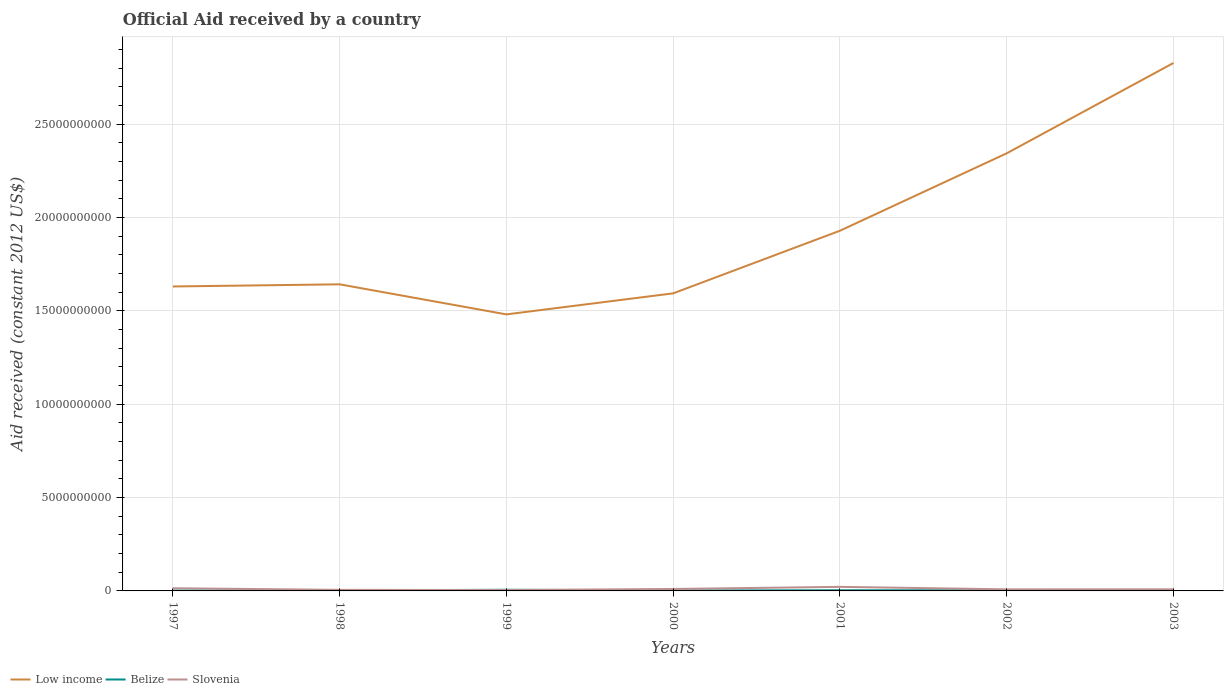Does the line corresponding to Slovenia intersect with the line corresponding to Low income?
Your answer should be very brief. No. Across all years, what is the maximum net official aid received in Slovenia?
Your answer should be very brief. 4.79e+07. In which year was the net official aid received in Belize maximum?
Ensure brevity in your answer.  2003. What is the total net official aid received in Low income in the graph?
Your answer should be very brief. -4.84e+09. What is the difference between the highest and the second highest net official aid received in Belize?
Offer a very short reply. 4.68e+07. How many years are there in the graph?
Offer a very short reply. 7. What is the difference between two consecutive major ticks on the Y-axis?
Provide a short and direct response. 5.00e+09. Are the values on the major ticks of Y-axis written in scientific E-notation?
Make the answer very short. No. Does the graph contain any zero values?
Offer a terse response. No. Where does the legend appear in the graph?
Give a very brief answer. Bottom left. How are the legend labels stacked?
Give a very brief answer. Horizontal. What is the title of the graph?
Offer a terse response. Official Aid received by a country. What is the label or title of the Y-axis?
Your answer should be compact. Aid received (constant 2012 US$). What is the Aid received (constant 2012 US$) of Low income in 1997?
Provide a short and direct response. 1.63e+1. What is the Aid received (constant 2012 US$) in Belize in 1997?
Make the answer very short. 2.03e+07. What is the Aid received (constant 2012 US$) of Slovenia in 1997?
Offer a very short reply. 1.43e+08. What is the Aid received (constant 2012 US$) in Low income in 1998?
Offer a very short reply. 1.64e+1. What is the Aid received (constant 2012 US$) in Belize in 1998?
Give a very brief answer. 2.22e+07. What is the Aid received (constant 2012 US$) of Slovenia in 1998?
Provide a succinct answer. 5.76e+07. What is the Aid received (constant 2012 US$) of Low income in 1999?
Ensure brevity in your answer.  1.48e+1. What is the Aid received (constant 2012 US$) in Belize in 1999?
Your answer should be very brief. 6.24e+07. What is the Aid received (constant 2012 US$) in Slovenia in 1999?
Provide a succinct answer. 4.79e+07. What is the Aid received (constant 2012 US$) of Low income in 2000?
Your answer should be very brief. 1.59e+1. What is the Aid received (constant 2012 US$) of Belize in 2000?
Make the answer very short. 2.36e+07. What is the Aid received (constant 2012 US$) in Slovenia in 2000?
Give a very brief answer. 1.04e+08. What is the Aid received (constant 2012 US$) in Low income in 2001?
Your answer should be very brief. 1.93e+1. What is the Aid received (constant 2012 US$) of Belize in 2001?
Provide a short and direct response. 3.48e+07. What is the Aid received (constant 2012 US$) in Slovenia in 2001?
Keep it short and to the point. 2.18e+08. What is the Aid received (constant 2012 US$) of Low income in 2002?
Ensure brevity in your answer.  2.34e+1. What is the Aid received (constant 2012 US$) of Belize in 2002?
Make the answer very short. 3.36e+07. What is the Aid received (constant 2012 US$) of Slovenia in 2002?
Keep it short and to the point. 8.46e+07. What is the Aid received (constant 2012 US$) of Low income in 2003?
Give a very brief answer. 2.83e+1. What is the Aid received (constant 2012 US$) in Belize in 2003?
Offer a very short reply. 1.56e+07. What is the Aid received (constant 2012 US$) in Slovenia in 2003?
Offer a terse response. 8.71e+07. Across all years, what is the maximum Aid received (constant 2012 US$) in Low income?
Your answer should be very brief. 2.83e+1. Across all years, what is the maximum Aid received (constant 2012 US$) in Belize?
Keep it short and to the point. 6.24e+07. Across all years, what is the maximum Aid received (constant 2012 US$) in Slovenia?
Offer a terse response. 2.18e+08. Across all years, what is the minimum Aid received (constant 2012 US$) in Low income?
Ensure brevity in your answer.  1.48e+1. Across all years, what is the minimum Aid received (constant 2012 US$) in Belize?
Provide a succinct answer. 1.56e+07. Across all years, what is the minimum Aid received (constant 2012 US$) of Slovenia?
Give a very brief answer. 4.79e+07. What is the total Aid received (constant 2012 US$) of Low income in the graph?
Provide a succinct answer. 1.35e+11. What is the total Aid received (constant 2012 US$) in Belize in the graph?
Give a very brief answer. 2.13e+08. What is the total Aid received (constant 2012 US$) in Slovenia in the graph?
Offer a terse response. 7.42e+08. What is the difference between the Aid received (constant 2012 US$) in Low income in 1997 and that in 1998?
Ensure brevity in your answer.  -1.15e+08. What is the difference between the Aid received (constant 2012 US$) in Belize in 1997 and that in 1998?
Give a very brief answer. -1.86e+06. What is the difference between the Aid received (constant 2012 US$) of Slovenia in 1997 and that in 1998?
Provide a succinct answer. 8.52e+07. What is the difference between the Aid received (constant 2012 US$) in Low income in 1997 and that in 1999?
Make the answer very short. 1.50e+09. What is the difference between the Aid received (constant 2012 US$) in Belize in 1997 and that in 1999?
Make the answer very short. -4.21e+07. What is the difference between the Aid received (constant 2012 US$) in Slovenia in 1997 and that in 1999?
Make the answer very short. 9.50e+07. What is the difference between the Aid received (constant 2012 US$) in Low income in 1997 and that in 2000?
Provide a short and direct response. 3.69e+08. What is the difference between the Aid received (constant 2012 US$) in Belize in 1997 and that in 2000?
Provide a succinct answer. -3.32e+06. What is the difference between the Aid received (constant 2012 US$) in Slovenia in 1997 and that in 2000?
Offer a terse response. 3.85e+07. What is the difference between the Aid received (constant 2012 US$) of Low income in 1997 and that in 2001?
Your answer should be very brief. -2.98e+09. What is the difference between the Aid received (constant 2012 US$) of Belize in 1997 and that in 2001?
Make the answer very short. -1.45e+07. What is the difference between the Aid received (constant 2012 US$) of Slovenia in 1997 and that in 2001?
Offer a terse response. -7.48e+07. What is the difference between the Aid received (constant 2012 US$) of Low income in 1997 and that in 2002?
Provide a short and direct response. -7.13e+09. What is the difference between the Aid received (constant 2012 US$) of Belize in 1997 and that in 2002?
Ensure brevity in your answer.  -1.32e+07. What is the difference between the Aid received (constant 2012 US$) of Slovenia in 1997 and that in 2002?
Give a very brief answer. 5.83e+07. What is the difference between the Aid received (constant 2012 US$) in Low income in 1997 and that in 2003?
Provide a succinct answer. -1.20e+1. What is the difference between the Aid received (constant 2012 US$) of Belize in 1997 and that in 2003?
Offer a terse response. 4.70e+06. What is the difference between the Aid received (constant 2012 US$) in Slovenia in 1997 and that in 2003?
Your response must be concise. 5.58e+07. What is the difference between the Aid received (constant 2012 US$) in Low income in 1998 and that in 1999?
Your answer should be compact. 1.61e+09. What is the difference between the Aid received (constant 2012 US$) in Belize in 1998 and that in 1999?
Your answer should be very brief. -4.02e+07. What is the difference between the Aid received (constant 2012 US$) in Slovenia in 1998 and that in 1999?
Your answer should be compact. 9.79e+06. What is the difference between the Aid received (constant 2012 US$) in Low income in 1998 and that in 2000?
Provide a succinct answer. 4.84e+08. What is the difference between the Aid received (constant 2012 US$) in Belize in 1998 and that in 2000?
Give a very brief answer. -1.46e+06. What is the difference between the Aid received (constant 2012 US$) of Slovenia in 1998 and that in 2000?
Provide a succinct answer. -4.67e+07. What is the difference between the Aid received (constant 2012 US$) of Low income in 1998 and that in 2001?
Give a very brief answer. -2.87e+09. What is the difference between the Aid received (constant 2012 US$) in Belize in 1998 and that in 2001?
Make the answer very short. -1.26e+07. What is the difference between the Aid received (constant 2012 US$) in Slovenia in 1998 and that in 2001?
Offer a very short reply. -1.60e+08. What is the difference between the Aid received (constant 2012 US$) in Low income in 1998 and that in 2002?
Your answer should be very brief. -7.02e+09. What is the difference between the Aid received (constant 2012 US$) in Belize in 1998 and that in 2002?
Keep it short and to the point. -1.14e+07. What is the difference between the Aid received (constant 2012 US$) in Slovenia in 1998 and that in 2002?
Offer a very short reply. -2.69e+07. What is the difference between the Aid received (constant 2012 US$) in Low income in 1998 and that in 2003?
Offer a terse response. -1.19e+1. What is the difference between the Aid received (constant 2012 US$) in Belize in 1998 and that in 2003?
Provide a short and direct response. 6.56e+06. What is the difference between the Aid received (constant 2012 US$) in Slovenia in 1998 and that in 2003?
Ensure brevity in your answer.  -2.95e+07. What is the difference between the Aid received (constant 2012 US$) in Low income in 1999 and that in 2000?
Ensure brevity in your answer.  -1.13e+09. What is the difference between the Aid received (constant 2012 US$) in Belize in 1999 and that in 2000?
Keep it short and to the point. 3.87e+07. What is the difference between the Aid received (constant 2012 US$) of Slovenia in 1999 and that in 2000?
Provide a short and direct response. -5.65e+07. What is the difference between the Aid received (constant 2012 US$) of Low income in 1999 and that in 2001?
Offer a very short reply. -4.48e+09. What is the difference between the Aid received (constant 2012 US$) in Belize in 1999 and that in 2001?
Offer a terse response. 2.76e+07. What is the difference between the Aid received (constant 2012 US$) in Slovenia in 1999 and that in 2001?
Ensure brevity in your answer.  -1.70e+08. What is the difference between the Aid received (constant 2012 US$) in Low income in 1999 and that in 2002?
Provide a short and direct response. -8.63e+09. What is the difference between the Aid received (constant 2012 US$) in Belize in 1999 and that in 2002?
Make the answer very short. 2.88e+07. What is the difference between the Aid received (constant 2012 US$) of Slovenia in 1999 and that in 2002?
Ensure brevity in your answer.  -3.67e+07. What is the difference between the Aid received (constant 2012 US$) of Low income in 1999 and that in 2003?
Provide a succinct answer. -1.35e+1. What is the difference between the Aid received (constant 2012 US$) in Belize in 1999 and that in 2003?
Ensure brevity in your answer.  4.68e+07. What is the difference between the Aid received (constant 2012 US$) of Slovenia in 1999 and that in 2003?
Give a very brief answer. -3.93e+07. What is the difference between the Aid received (constant 2012 US$) of Low income in 2000 and that in 2001?
Keep it short and to the point. -3.35e+09. What is the difference between the Aid received (constant 2012 US$) of Belize in 2000 and that in 2001?
Your response must be concise. -1.12e+07. What is the difference between the Aid received (constant 2012 US$) of Slovenia in 2000 and that in 2001?
Offer a terse response. -1.13e+08. What is the difference between the Aid received (constant 2012 US$) in Low income in 2000 and that in 2002?
Make the answer very short. -7.50e+09. What is the difference between the Aid received (constant 2012 US$) in Belize in 2000 and that in 2002?
Provide a succinct answer. -9.92e+06. What is the difference between the Aid received (constant 2012 US$) of Slovenia in 2000 and that in 2002?
Make the answer very short. 1.98e+07. What is the difference between the Aid received (constant 2012 US$) in Low income in 2000 and that in 2003?
Provide a short and direct response. -1.23e+1. What is the difference between the Aid received (constant 2012 US$) of Belize in 2000 and that in 2003?
Your answer should be compact. 8.02e+06. What is the difference between the Aid received (constant 2012 US$) of Slovenia in 2000 and that in 2003?
Your response must be concise. 1.72e+07. What is the difference between the Aid received (constant 2012 US$) in Low income in 2001 and that in 2002?
Give a very brief answer. -4.15e+09. What is the difference between the Aid received (constant 2012 US$) of Belize in 2001 and that in 2002?
Your answer should be compact. 1.25e+06. What is the difference between the Aid received (constant 2012 US$) of Slovenia in 2001 and that in 2002?
Provide a succinct answer. 1.33e+08. What is the difference between the Aid received (constant 2012 US$) in Low income in 2001 and that in 2003?
Provide a short and direct response. -8.99e+09. What is the difference between the Aid received (constant 2012 US$) in Belize in 2001 and that in 2003?
Your answer should be compact. 1.92e+07. What is the difference between the Aid received (constant 2012 US$) of Slovenia in 2001 and that in 2003?
Give a very brief answer. 1.30e+08. What is the difference between the Aid received (constant 2012 US$) in Low income in 2002 and that in 2003?
Offer a terse response. -4.84e+09. What is the difference between the Aid received (constant 2012 US$) in Belize in 2002 and that in 2003?
Ensure brevity in your answer.  1.79e+07. What is the difference between the Aid received (constant 2012 US$) of Slovenia in 2002 and that in 2003?
Offer a terse response. -2.54e+06. What is the difference between the Aid received (constant 2012 US$) in Low income in 1997 and the Aid received (constant 2012 US$) in Belize in 1998?
Give a very brief answer. 1.63e+1. What is the difference between the Aid received (constant 2012 US$) in Low income in 1997 and the Aid received (constant 2012 US$) in Slovenia in 1998?
Give a very brief answer. 1.63e+1. What is the difference between the Aid received (constant 2012 US$) in Belize in 1997 and the Aid received (constant 2012 US$) in Slovenia in 1998?
Your answer should be compact. -3.73e+07. What is the difference between the Aid received (constant 2012 US$) in Low income in 1997 and the Aid received (constant 2012 US$) in Belize in 1999?
Keep it short and to the point. 1.62e+1. What is the difference between the Aid received (constant 2012 US$) of Low income in 1997 and the Aid received (constant 2012 US$) of Slovenia in 1999?
Ensure brevity in your answer.  1.63e+1. What is the difference between the Aid received (constant 2012 US$) in Belize in 1997 and the Aid received (constant 2012 US$) in Slovenia in 1999?
Provide a short and direct response. -2.75e+07. What is the difference between the Aid received (constant 2012 US$) of Low income in 1997 and the Aid received (constant 2012 US$) of Belize in 2000?
Ensure brevity in your answer.  1.63e+1. What is the difference between the Aid received (constant 2012 US$) of Low income in 1997 and the Aid received (constant 2012 US$) of Slovenia in 2000?
Ensure brevity in your answer.  1.62e+1. What is the difference between the Aid received (constant 2012 US$) of Belize in 1997 and the Aid received (constant 2012 US$) of Slovenia in 2000?
Provide a short and direct response. -8.40e+07. What is the difference between the Aid received (constant 2012 US$) of Low income in 1997 and the Aid received (constant 2012 US$) of Belize in 2001?
Ensure brevity in your answer.  1.63e+1. What is the difference between the Aid received (constant 2012 US$) in Low income in 1997 and the Aid received (constant 2012 US$) in Slovenia in 2001?
Your response must be concise. 1.61e+1. What is the difference between the Aid received (constant 2012 US$) of Belize in 1997 and the Aid received (constant 2012 US$) of Slovenia in 2001?
Keep it short and to the point. -1.97e+08. What is the difference between the Aid received (constant 2012 US$) in Low income in 1997 and the Aid received (constant 2012 US$) in Belize in 2002?
Ensure brevity in your answer.  1.63e+1. What is the difference between the Aid received (constant 2012 US$) in Low income in 1997 and the Aid received (constant 2012 US$) in Slovenia in 2002?
Ensure brevity in your answer.  1.62e+1. What is the difference between the Aid received (constant 2012 US$) in Belize in 1997 and the Aid received (constant 2012 US$) in Slovenia in 2002?
Offer a terse response. -6.42e+07. What is the difference between the Aid received (constant 2012 US$) in Low income in 1997 and the Aid received (constant 2012 US$) in Belize in 2003?
Provide a succinct answer. 1.63e+1. What is the difference between the Aid received (constant 2012 US$) of Low income in 1997 and the Aid received (constant 2012 US$) of Slovenia in 2003?
Provide a short and direct response. 1.62e+1. What is the difference between the Aid received (constant 2012 US$) in Belize in 1997 and the Aid received (constant 2012 US$) in Slovenia in 2003?
Provide a succinct answer. -6.68e+07. What is the difference between the Aid received (constant 2012 US$) in Low income in 1998 and the Aid received (constant 2012 US$) in Belize in 1999?
Your response must be concise. 1.64e+1. What is the difference between the Aid received (constant 2012 US$) in Low income in 1998 and the Aid received (constant 2012 US$) in Slovenia in 1999?
Give a very brief answer. 1.64e+1. What is the difference between the Aid received (constant 2012 US$) in Belize in 1998 and the Aid received (constant 2012 US$) in Slovenia in 1999?
Give a very brief answer. -2.57e+07. What is the difference between the Aid received (constant 2012 US$) in Low income in 1998 and the Aid received (constant 2012 US$) in Belize in 2000?
Your answer should be compact. 1.64e+1. What is the difference between the Aid received (constant 2012 US$) in Low income in 1998 and the Aid received (constant 2012 US$) in Slovenia in 2000?
Offer a terse response. 1.63e+1. What is the difference between the Aid received (constant 2012 US$) of Belize in 1998 and the Aid received (constant 2012 US$) of Slovenia in 2000?
Keep it short and to the point. -8.22e+07. What is the difference between the Aid received (constant 2012 US$) of Low income in 1998 and the Aid received (constant 2012 US$) of Belize in 2001?
Make the answer very short. 1.64e+1. What is the difference between the Aid received (constant 2012 US$) of Low income in 1998 and the Aid received (constant 2012 US$) of Slovenia in 2001?
Keep it short and to the point. 1.62e+1. What is the difference between the Aid received (constant 2012 US$) of Belize in 1998 and the Aid received (constant 2012 US$) of Slovenia in 2001?
Offer a very short reply. -1.95e+08. What is the difference between the Aid received (constant 2012 US$) in Low income in 1998 and the Aid received (constant 2012 US$) in Belize in 2002?
Offer a terse response. 1.64e+1. What is the difference between the Aid received (constant 2012 US$) of Low income in 1998 and the Aid received (constant 2012 US$) of Slovenia in 2002?
Your answer should be compact. 1.63e+1. What is the difference between the Aid received (constant 2012 US$) of Belize in 1998 and the Aid received (constant 2012 US$) of Slovenia in 2002?
Provide a succinct answer. -6.24e+07. What is the difference between the Aid received (constant 2012 US$) in Low income in 1998 and the Aid received (constant 2012 US$) in Belize in 2003?
Your answer should be very brief. 1.64e+1. What is the difference between the Aid received (constant 2012 US$) of Low income in 1998 and the Aid received (constant 2012 US$) of Slovenia in 2003?
Your answer should be very brief. 1.63e+1. What is the difference between the Aid received (constant 2012 US$) of Belize in 1998 and the Aid received (constant 2012 US$) of Slovenia in 2003?
Your answer should be very brief. -6.49e+07. What is the difference between the Aid received (constant 2012 US$) in Low income in 1999 and the Aid received (constant 2012 US$) in Belize in 2000?
Give a very brief answer. 1.48e+1. What is the difference between the Aid received (constant 2012 US$) of Low income in 1999 and the Aid received (constant 2012 US$) of Slovenia in 2000?
Your answer should be compact. 1.47e+1. What is the difference between the Aid received (constant 2012 US$) in Belize in 1999 and the Aid received (constant 2012 US$) in Slovenia in 2000?
Give a very brief answer. -4.20e+07. What is the difference between the Aid received (constant 2012 US$) in Low income in 1999 and the Aid received (constant 2012 US$) in Belize in 2001?
Keep it short and to the point. 1.48e+1. What is the difference between the Aid received (constant 2012 US$) of Low income in 1999 and the Aid received (constant 2012 US$) of Slovenia in 2001?
Make the answer very short. 1.46e+1. What is the difference between the Aid received (constant 2012 US$) in Belize in 1999 and the Aid received (constant 2012 US$) in Slovenia in 2001?
Provide a succinct answer. -1.55e+08. What is the difference between the Aid received (constant 2012 US$) in Low income in 1999 and the Aid received (constant 2012 US$) in Belize in 2002?
Give a very brief answer. 1.48e+1. What is the difference between the Aid received (constant 2012 US$) of Low income in 1999 and the Aid received (constant 2012 US$) of Slovenia in 2002?
Give a very brief answer. 1.47e+1. What is the difference between the Aid received (constant 2012 US$) of Belize in 1999 and the Aid received (constant 2012 US$) of Slovenia in 2002?
Keep it short and to the point. -2.22e+07. What is the difference between the Aid received (constant 2012 US$) in Low income in 1999 and the Aid received (constant 2012 US$) in Belize in 2003?
Provide a succinct answer. 1.48e+1. What is the difference between the Aid received (constant 2012 US$) in Low income in 1999 and the Aid received (constant 2012 US$) in Slovenia in 2003?
Provide a succinct answer. 1.47e+1. What is the difference between the Aid received (constant 2012 US$) of Belize in 1999 and the Aid received (constant 2012 US$) of Slovenia in 2003?
Ensure brevity in your answer.  -2.47e+07. What is the difference between the Aid received (constant 2012 US$) of Low income in 2000 and the Aid received (constant 2012 US$) of Belize in 2001?
Offer a terse response. 1.59e+1. What is the difference between the Aid received (constant 2012 US$) in Low income in 2000 and the Aid received (constant 2012 US$) in Slovenia in 2001?
Offer a very short reply. 1.57e+1. What is the difference between the Aid received (constant 2012 US$) of Belize in 2000 and the Aid received (constant 2012 US$) of Slovenia in 2001?
Offer a terse response. -1.94e+08. What is the difference between the Aid received (constant 2012 US$) of Low income in 2000 and the Aid received (constant 2012 US$) of Belize in 2002?
Offer a very short reply. 1.59e+1. What is the difference between the Aid received (constant 2012 US$) of Low income in 2000 and the Aid received (constant 2012 US$) of Slovenia in 2002?
Make the answer very short. 1.59e+1. What is the difference between the Aid received (constant 2012 US$) in Belize in 2000 and the Aid received (constant 2012 US$) in Slovenia in 2002?
Give a very brief answer. -6.09e+07. What is the difference between the Aid received (constant 2012 US$) of Low income in 2000 and the Aid received (constant 2012 US$) of Belize in 2003?
Your answer should be compact. 1.59e+1. What is the difference between the Aid received (constant 2012 US$) of Low income in 2000 and the Aid received (constant 2012 US$) of Slovenia in 2003?
Your answer should be very brief. 1.59e+1. What is the difference between the Aid received (constant 2012 US$) of Belize in 2000 and the Aid received (constant 2012 US$) of Slovenia in 2003?
Keep it short and to the point. -6.35e+07. What is the difference between the Aid received (constant 2012 US$) of Low income in 2001 and the Aid received (constant 2012 US$) of Belize in 2002?
Offer a terse response. 1.93e+1. What is the difference between the Aid received (constant 2012 US$) in Low income in 2001 and the Aid received (constant 2012 US$) in Slovenia in 2002?
Offer a terse response. 1.92e+1. What is the difference between the Aid received (constant 2012 US$) of Belize in 2001 and the Aid received (constant 2012 US$) of Slovenia in 2002?
Keep it short and to the point. -4.98e+07. What is the difference between the Aid received (constant 2012 US$) of Low income in 2001 and the Aid received (constant 2012 US$) of Belize in 2003?
Provide a short and direct response. 1.93e+1. What is the difference between the Aid received (constant 2012 US$) in Low income in 2001 and the Aid received (constant 2012 US$) in Slovenia in 2003?
Keep it short and to the point. 1.92e+1. What is the difference between the Aid received (constant 2012 US$) in Belize in 2001 and the Aid received (constant 2012 US$) in Slovenia in 2003?
Keep it short and to the point. -5.23e+07. What is the difference between the Aid received (constant 2012 US$) of Low income in 2002 and the Aid received (constant 2012 US$) of Belize in 2003?
Provide a short and direct response. 2.34e+1. What is the difference between the Aid received (constant 2012 US$) in Low income in 2002 and the Aid received (constant 2012 US$) in Slovenia in 2003?
Ensure brevity in your answer.  2.34e+1. What is the difference between the Aid received (constant 2012 US$) of Belize in 2002 and the Aid received (constant 2012 US$) of Slovenia in 2003?
Offer a terse response. -5.36e+07. What is the average Aid received (constant 2012 US$) in Low income per year?
Offer a very short reply. 1.92e+1. What is the average Aid received (constant 2012 US$) of Belize per year?
Keep it short and to the point. 3.04e+07. What is the average Aid received (constant 2012 US$) in Slovenia per year?
Provide a succinct answer. 1.06e+08. In the year 1997, what is the difference between the Aid received (constant 2012 US$) in Low income and Aid received (constant 2012 US$) in Belize?
Give a very brief answer. 1.63e+1. In the year 1997, what is the difference between the Aid received (constant 2012 US$) of Low income and Aid received (constant 2012 US$) of Slovenia?
Offer a terse response. 1.62e+1. In the year 1997, what is the difference between the Aid received (constant 2012 US$) in Belize and Aid received (constant 2012 US$) in Slovenia?
Your answer should be compact. -1.23e+08. In the year 1998, what is the difference between the Aid received (constant 2012 US$) in Low income and Aid received (constant 2012 US$) in Belize?
Keep it short and to the point. 1.64e+1. In the year 1998, what is the difference between the Aid received (constant 2012 US$) of Low income and Aid received (constant 2012 US$) of Slovenia?
Ensure brevity in your answer.  1.64e+1. In the year 1998, what is the difference between the Aid received (constant 2012 US$) of Belize and Aid received (constant 2012 US$) of Slovenia?
Your response must be concise. -3.55e+07. In the year 1999, what is the difference between the Aid received (constant 2012 US$) of Low income and Aid received (constant 2012 US$) of Belize?
Ensure brevity in your answer.  1.48e+1. In the year 1999, what is the difference between the Aid received (constant 2012 US$) of Low income and Aid received (constant 2012 US$) of Slovenia?
Offer a terse response. 1.48e+1. In the year 1999, what is the difference between the Aid received (constant 2012 US$) in Belize and Aid received (constant 2012 US$) in Slovenia?
Make the answer very short. 1.45e+07. In the year 2000, what is the difference between the Aid received (constant 2012 US$) in Low income and Aid received (constant 2012 US$) in Belize?
Your answer should be very brief. 1.59e+1. In the year 2000, what is the difference between the Aid received (constant 2012 US$) of Low income and Aid received (constant 2012 US$) of Slovenia?
Make the answer very short. 1.58e+1. In the year 2000, what is the difference between the Aid received (constant 2012 US$) in Belize and Aid received (constant 2012 US$) in Slovenia?
Your answer should be very brief. -8.07e+07. In the year 2001, what is the difference between the Aid received (constant 2012 US$) of Low income and Aid received (constant 2012 US$) of Belize?
Provide a short and direct response. 1.93e+1. In the year 2001, what is the difference between the Aid received (constant 2012 US$) in Low income and Aid received (constant 2012 US$) in Slovenia?
Provide a succinct answer. 1.91e+1. In the year 2001, what is the difference between the Aid received (constant 2012 US$) of Belize and Aid received (constant 2012 US$) of Slovenia?
Make the answer very short. -1.83e+08. In the year 2002, what is the difference between the Aid received (constant 2012 US$) of Low income and Aid received (constant 2012 US$) of Belize?
Give a very brief answer. 2.34e+1. In the year 2002, what is the difference between the Aid received (constant 2012 US$) of Low income and Aid received (constant 2012 US$) of Slovenia?
Offer a terse response. 2.34e+1. In the year 2002, what is the difference between the Aid received (constant 2012 US$) of Belize and Aid received (constant 2012 US$) of Slovenia?
Your answer should be very brief. -5.10e+07. In the year 2003, what is the difference between the Aid received (constant 2012 US$) in Low income and Aid received (constant 2012 US$) in Belize?
Your answer should be compact. 2.83e+1. In the year 2003, what is the difference between the Aid received (constant 2012 US$) of Low income and Aid received (constant 2012 US$) of Slovenia?
Provide a succinct answer. 2.82e+1. In the year 2003, what is the difference between the Aid received (constant 2012 US$) in Belize and Aid received (constant 2012 US$) in Slovenia?
Offer a very short reply. -7.15e+07. What is the ratio of the Aid received (constant 2012 US$) in Low income in 1997 to that in 1998?
Provide a succinct answer. 0.99. What is the ratio of the Aid received (constant 2012 US$) of Belize in 1997 to that in 1998?
Provide a short and direct response. 0.92. What is the ratio of the Aid received (constant 2012 US$) in Slovenia in 1997 to that in 1998?
Ensure brevity in your answer.  2.48. What is the ratio of the Aid received (constant 2012 US$) in Low income in 1997 to that in 1999?
Ensure brevity in your answer.  1.1. What is the ratio of the Aid received (constant 2012 US$) of Belize in 1997 to that in 1999?
Your response must be concise. 0.33. What is the ratio of the Aid received (constant 2012 US$) in Slovenia in 1997 to that in 1999?
Keep it short and to the point. 2.99. What is the ratio of the Aid received (constant 2012 US$) of Low income in 1997 to that in 2000?
Give a very brief answer. 1.02. What is the ratio of the Aid received (constant 2012 US$) of Belize in 1997 to that in 2000?
Your answer should be very brief. 0.86. What is the ratio of the Aid received (constant 2012 US$) in Slovenia in 1997 to that in 2000?
Your response must be concise. 1.37. What is the ratio of the Aid received (constant 2012 US$) of Low income in 1997 to that in 2001?
Make the answer very short. 0.85. What is the ratio of the Aid received (constant 2012 US$) of Belize in 1997 to that in 2001?
Your response must be concise. 0.58. What is the ratio of the Aid received (constant 2012 US$) in Slovenia in 1997 to that in 2001?
Your answer should be very brief. 0.66. What is the ratio of the Aid received (constant 2012 US$) in Low income in 1997 to that in 2002?
Ensure brevity in your answer.  0.7. What is the ratio of the Aid received (constant 2012 US$) of Belize in 1997 to that in 2002?
Make the answer very short. 0.61. What is the ratio of the Aid received (constant 2012 US$) of Slovenia in 1997 to that in 2002?
Your answer should be very brief. 1.69. What is the ratio of the Aid received (constant 2012 US$) of Low income in 1997 to that in 2003?
Offer a terse response. 0.58. What is the ratio of the Aid received (constant 2012 US$) in Belize in 1997 to that in 2003?
Your response must be concise. 1.3. What is the ratio of the Aid received (constant 2012 US$) of Slovenia in 1997 to that in 2003?
Offer a very short reply. 1.64. What is the ratio of the Aid received (constant 2012 US$) of Low income in 1998 to that in 1999?
Offer a terse response. 1.11. What is the ratio of the Aid received (constant 2012 US$) of Belize in 1998 to that in 1999?
Provide a short and direct response. 0.36. What is the ratio of the Aid received (constant 2012 US$) of Slovenia in 1998 to that in 1999?
Provide a short and direct response. 1.2. What is the ratio of the Aid received (constant 2012 US$) of Low income in 1998 to that in 2000?
Your response must be concise. 1.03. What is the ratio of the Aid received (constant 2012 US$) in Belize in 1998 to that in 2000?
Your response must be concise. 0.94. What is the ratio of the Aid received (constant 2012 US$) in Slovenia in 1998 to that in 2000?
Provide a short and direct response. 0.55. What is the ratio of the Aid received (constant 2012 US$) of Low income in 1998 to that in 2001?
Provide a succinct answer. 0.85. What is the ratio of the Aid received (constant 2012 US$) of Belize in 1998 to that in 2001?
Provide a short and direct response. 0.64. What is the ratio of the Aid received (constant 2012 US$) in Slovenia in 1998 to that in 2001?
Offer a very short reply. 0.26. What is the ratio of the Aid received (constant 2012 US$) of Low income in 1998 to that in 2002?
Your answer should be very brief. 0.7. What is the ratio of the Aid received (constant 2012 US$) in Belize in 1998 to that in 2002?
Provide a succinct answer. 0.66. What is the ratio of the Aid received (constant 2012 US$) in Slovenia in 1998 to that in 2002?
Your answer should be compact. 0.68. What is the ratio of the Aid received (constant 2012 US$) in Low income in 1998 to that in 2003?
Provide a short and direct response. 0.58. What is the ratio of the Aid received (constant 2012 US$) in Belize in 1998 to that in 2003?
Provide a short and direct response. 1.42. What is the ratio of the Aid received (constant 2012 US$) of Slovenia in 1998 to that in 2003?
Offer a very short reply. 0.66. What is the ratio of the Aid received (constant 2012 US$) of Low income in 1999 to that in 2000?
Offer a terse response. 0.93. What is the ratio of the Aid received (constant 2012 US$) of Belize in 1999 to that in 2000?
Keep it short and to the point. 2.64. What is the ratio of the Aid received (constant 2012 US$) in Slovenia in 1999 to that in 2000?
Offer a terse response. 0.46. What is the ratio of the Aid received (constant 2012 US$) in Low income in 1999 to that in 2001?
Your answer should be very brief. 0.77. What is the ratio of the Aid received (constant 2012 US$) in Belize in 1999 to that in 2001?
Give a very brief answer. 1.79. What is the ratio of the Aid received (constant 2012 US$) of Slovenia in 1999 to that in 2001?
Offer a terse response. 0.22. What is the ratio of the Aid received (constant 2012 US$) in Low income in 1999 to that in 2002?
Provide a short and direct response. 0.63. What is the ratio of the Aid received (constant 2012 US$) in Belize in 1999 to that in 2002?
Provide a succinct answer. 1.86. What is the ratio of the Aid received (constant 2012 US$) in Slovenia in 1999 to that in 2002?
Keep it short and to the point. 0.57. What is the ratio of the Aid received (constant 2012 US$) of Low income in 1999 to that in 2003?
Give a very brief answer. 0.52. What is the ratio of the Aid received (constant 2012 US$) of Belize in 1999 to that in 2003?
Give a very brief answer. 3.99. What is the ratio of the Aid received (constant 2012 US$) in Slovenia in 1999 to that in 2003?
Offer a terse response. 0.55. What is the ratio of the Aid received (constant 2012 US$) of Low income in 2000 to that in 2001?
Offer a terse response. 0.83. What is the ratio of the Aid received (constant 2012 US$) of Belize in 2000 to that in 2001?
Your answer should be very brief. 0.68. What is the ratio of the Aid received (constant 2012 US$) of Slovenia in 2000 to that in 2001?
Provide a short and direct response. 0.48. What is the ratio of the Aid received (constant 2012 US$) of Low income in 2000 to that in 2002?
Your answer should be compact. 0.68. What is the ratio of the Aid received (constant 2012 US$) in Belize in 2000 to that in 2002?
Your answer should be compact. 0.7. What is the ratio of the Aid received (constant 2012 US$) in Slovenia in 2000 to that in 2002?
Give a very brief answer. 1.23. What is the ratio of the Aid received (constant 2012 US$) of Low income in 2000 to that in 2003?
Provide a succinct answer. 0.56. What is the ratio of the Aid received (constant 2012 US$) of Belize in 2000 to that in 2003?
Your answer should be compact. 1.51. What is the ratio of the Aid received (constant 2012 US$) in Slovenia in 2000 to that in 2003?
Keep it short and to the point. 1.2. What is the ratio of the Aid received (constant 2012 US$) in Low income in 2001 to that in 2002?
Offer a very short reply. 0.82. What is the ratio of the Aid received (constant 2012 US$) in Belize in 2001 to that in 2002?
Keep it short and to the point. 1.04. What is the ratio of the Aid received (constant 2012 US$) of Slovenia in 2001 to that in 2002?
Provide a short and direct response. 2.57. What is the ratio of the Aid received (constant 2012 US$) in Low income in 2001 to that in 2003?
Ensure brevity in your answer.  0.68. What is the ratio of the Aid received (constant 2012 US$) of Belize in 2001 to that in 2003?
Your answer should be very brief. 2.23. What is the ratio of the Aid received (constant 2012 US$) of Slovenia in 2001 to that in 2003?
Provide a short and direct response. 2.5. What is the ratio of the Aid received (constant 2012 US$) in Low income in 2002 to that in 2003?
Ensure brevity in your answer.  0.83. What is the ratio of the Aid received (constant 2012 US$) of Belize in 2002 to that in 2003?
Keep it short and to the point. 2.15. What is the ratio of the Aid received (constant 2012 US$) in Slovenia in 2002 to that in 2003?
Keep it short and to the point. 0.97. What is the difference between the highest and the second highest Aid received (constant 2012 US$) of Low income?
Ensure brevity in your answer.  4.84e+09. What is the difference between the highest and the second highest Aid received (constant 2012 US$) in Belize?
Offer a terse response. 2.76e+07. What is the difference between the highest and the second highest Aid received (constant 2012 US$) in Slovenia?
Your response must be concise. 7.48e+07. What is the difference between the highest and the lowest Aid received (constant 2012 US$) in Low income?
Offer a terse response. 1.35e+1. What is the difference between the highest and the lowest Aid received (constant 2012 US$) of Belize?
Provide a short and direct response. 4.68e+07. What is the difference between the highest and the lowest Aid received (constant 2012 US$) of Slovenia?
Offer a very short reply. 1.70e+08. 